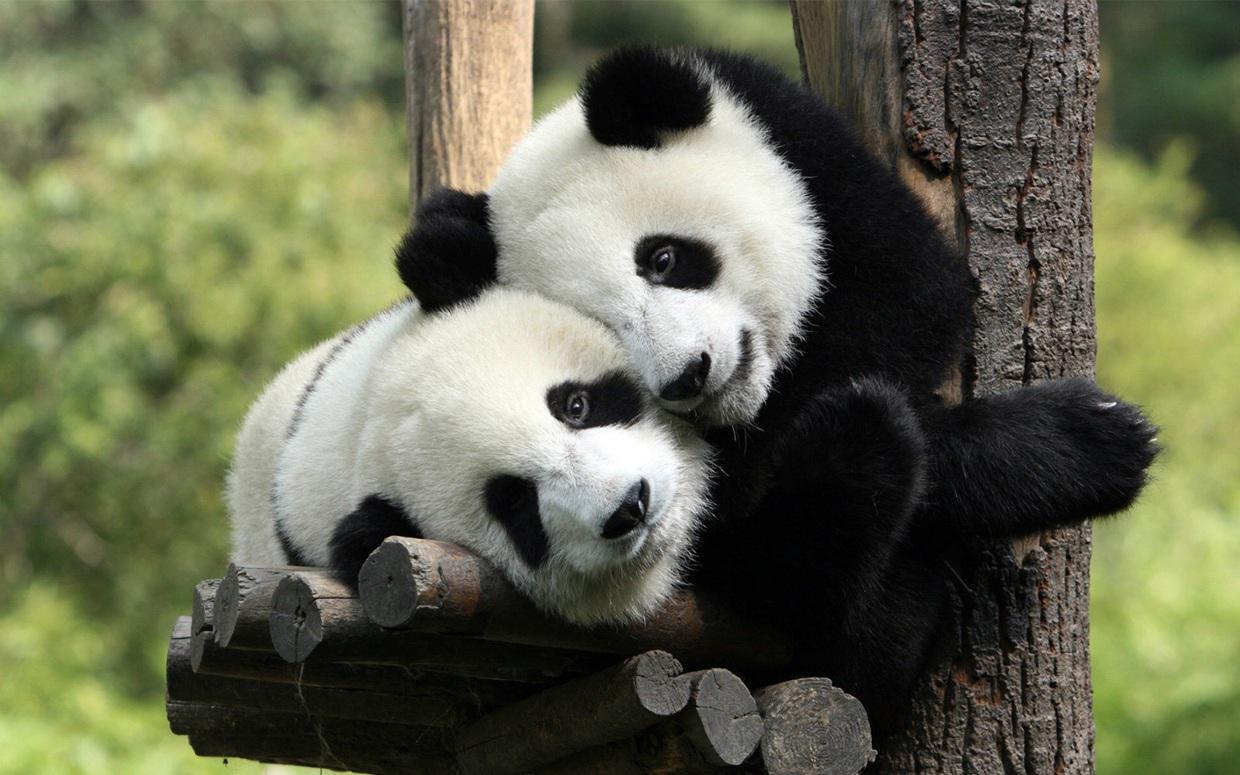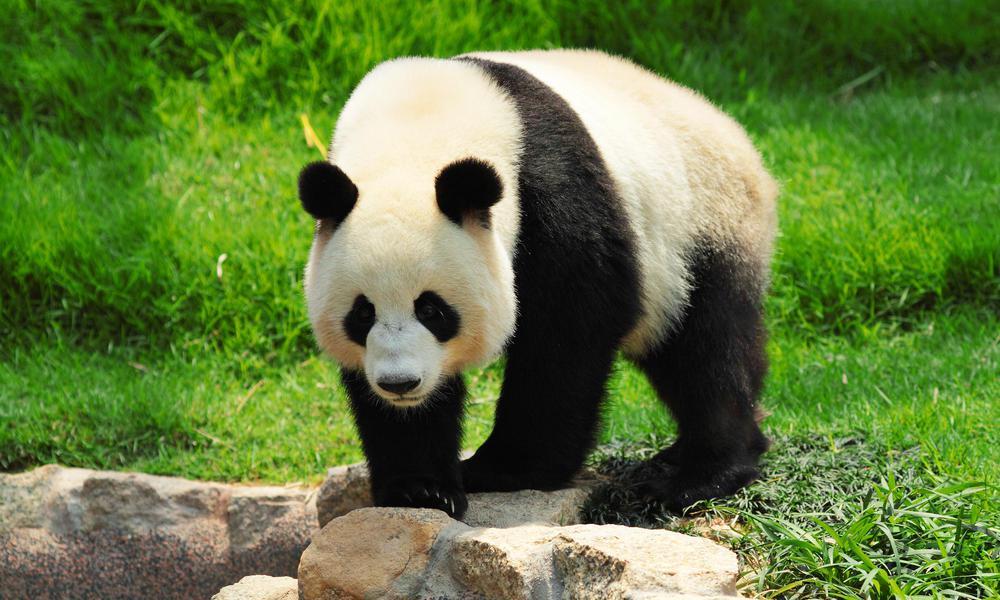The first image is the image on the left, the second image is the image on the right. For the images displayed, is the sentence "A baby panda is resting on its mother's chest" factually correct? Answer yes or no. No. 